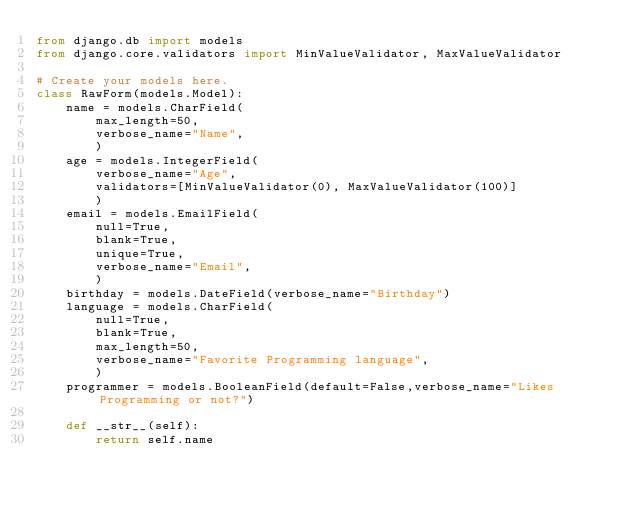Convert code to text. <code><loc_0><loc_0><loc_500><loc_500><_Python_>from django.db import models
from django.core.validators import MinValueValidator, MaxValueValidator

# Create your models here.
class RawForm(models.Model):
    name = models.CharField(
        max_length=50,
        verbose_name="Name",
        )
    age = models.IntegerField(
        verbose_name="Age",
        validators=[MinValueValidator(0), MaxValueValidator(100)]
        )
    email = models.EmailField(
        null=True,
        blank=True,
        unique=True,
        verbose_name="Email",
        )
    birthday = models.DateField(verbose_name="Birthday")
    language = models.CharField(
        null=True,
        blank=True,
        max_length=50,
        verbose_name="Favorite Programming language",
        )
    programmer = models.BooleanField(default=False,verbose_name="Likes Programming or not?")

    def __str__(self):
        return self.name
</code> 